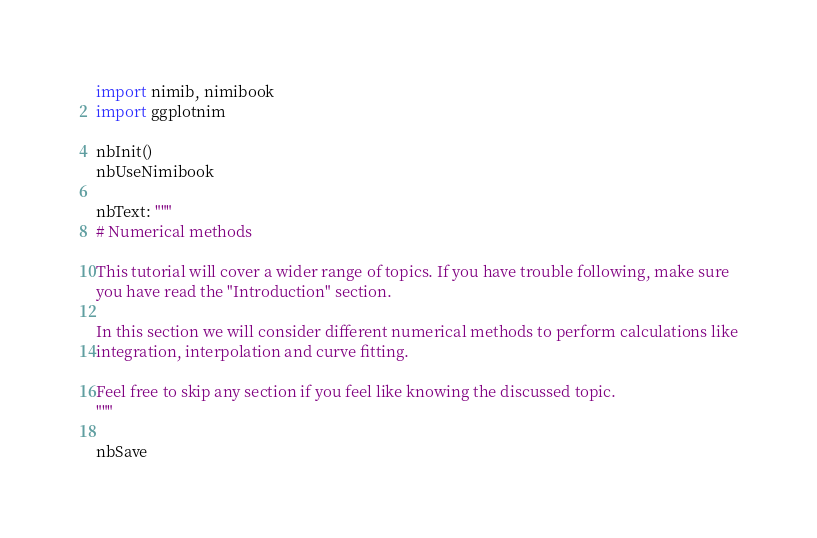Convert code to text. <code><loc_0><loc_0><loc_500><loc_500><_Nim_>import nimib, nimibook
import ggplotnim

nbInit()
nbUseNimibook

nbText: """
# Numerical methods

This tutorial will cover a wider range of topics. If you have trouble following, make sure
you have read the "Introduction" section.

In this section we will consider different numerical methods to perform calculations like
integration, interpolation and curve fitting.

Feel free to skip any section if you feel like knowing the discussed topic.
"""

nbSave
</code> 